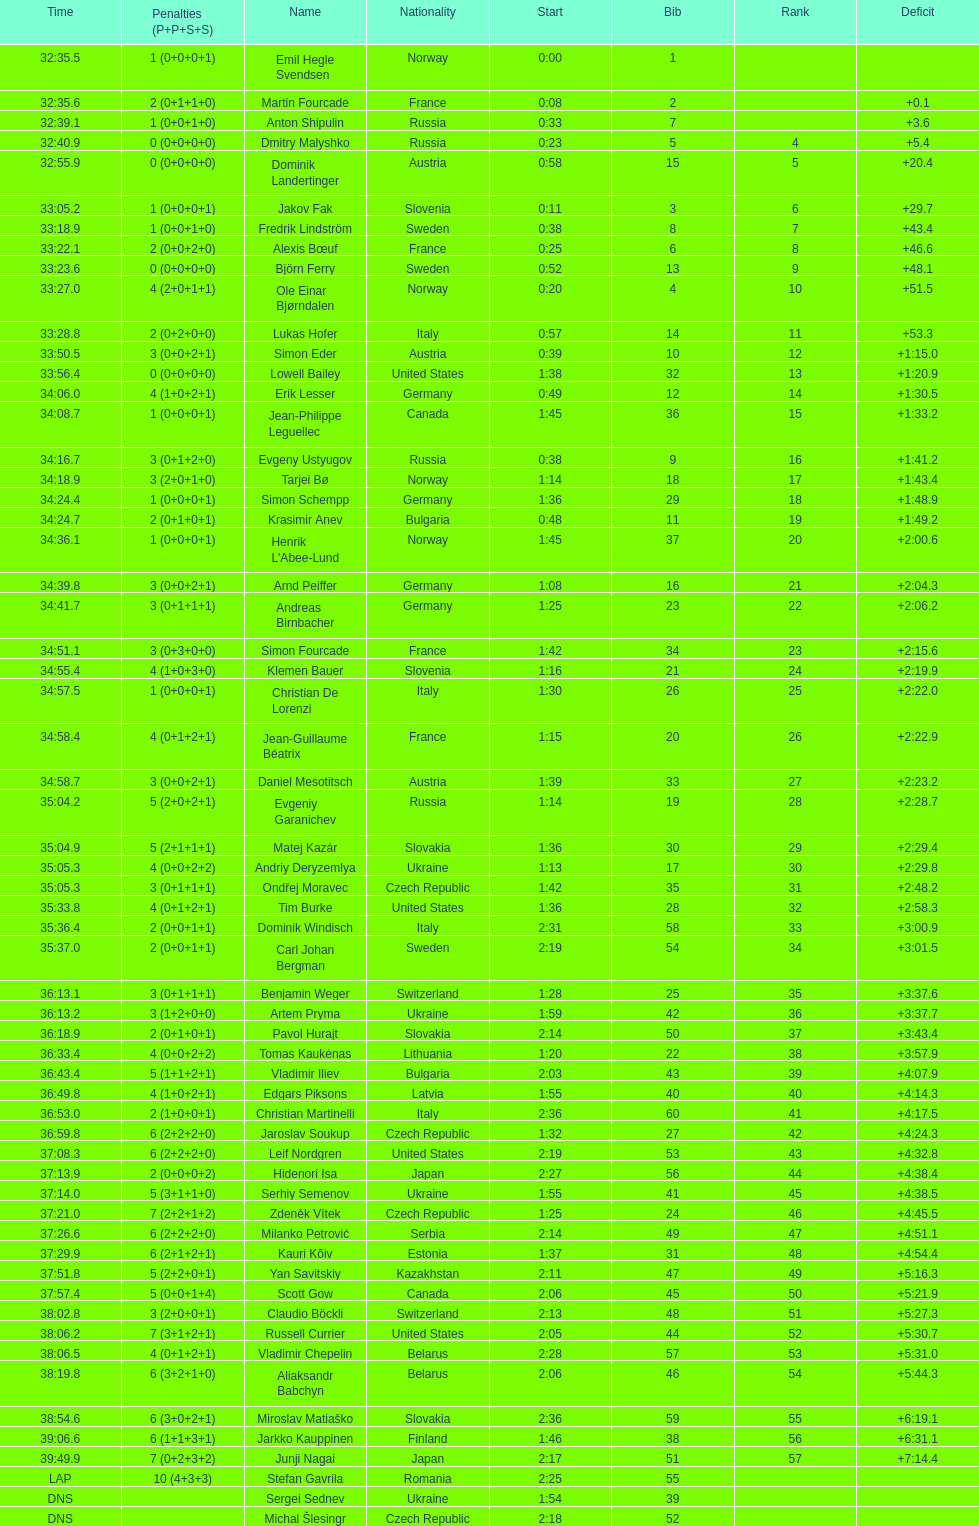What were the total number of "ties" (people who finished with the exact same time?) 2. 